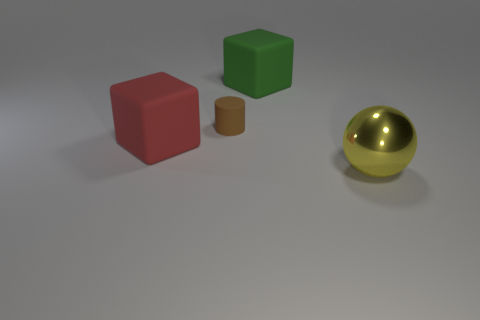Is the shape of the matte object that is on the right side of the cylinder the same as the big thing left of the big green rubber thing? While they both share a cylindrical shape, the object to the right of the gold sphere is smaller in size and has a different texture compared to the larger cylinder to the left of the green cube. 